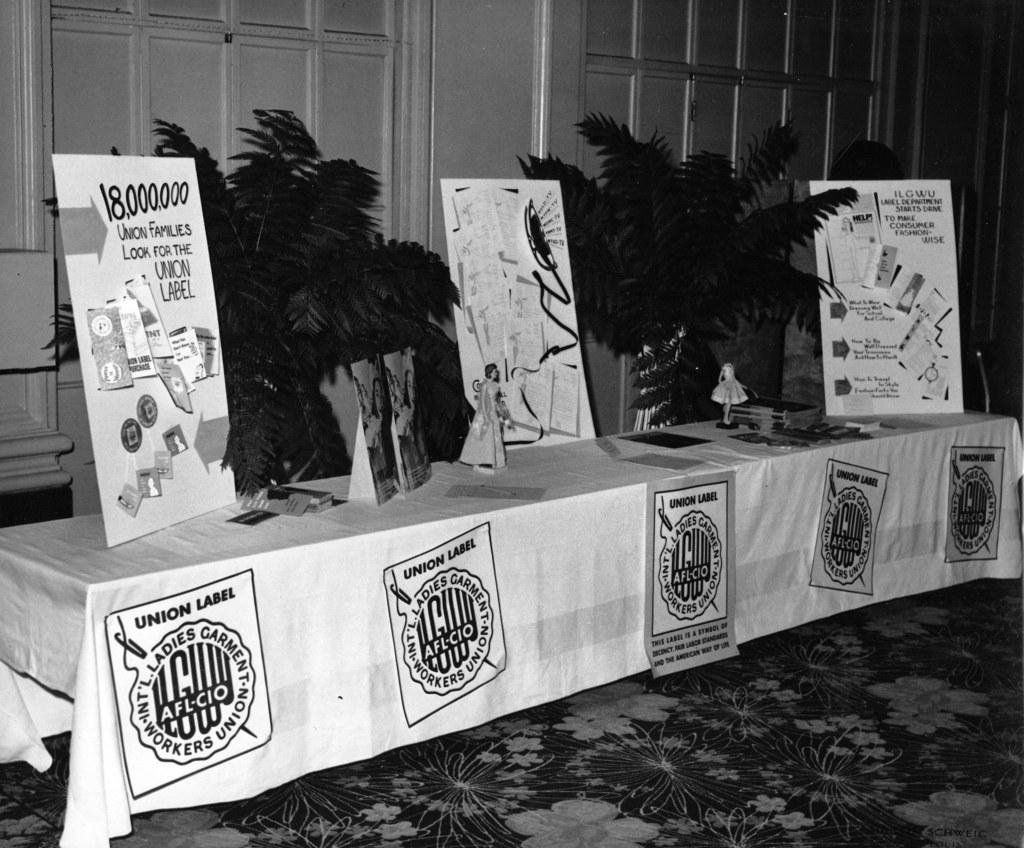Provide a one-sentence caption for the provided image. a table with poster for the Ladies Garment Workers Union. 